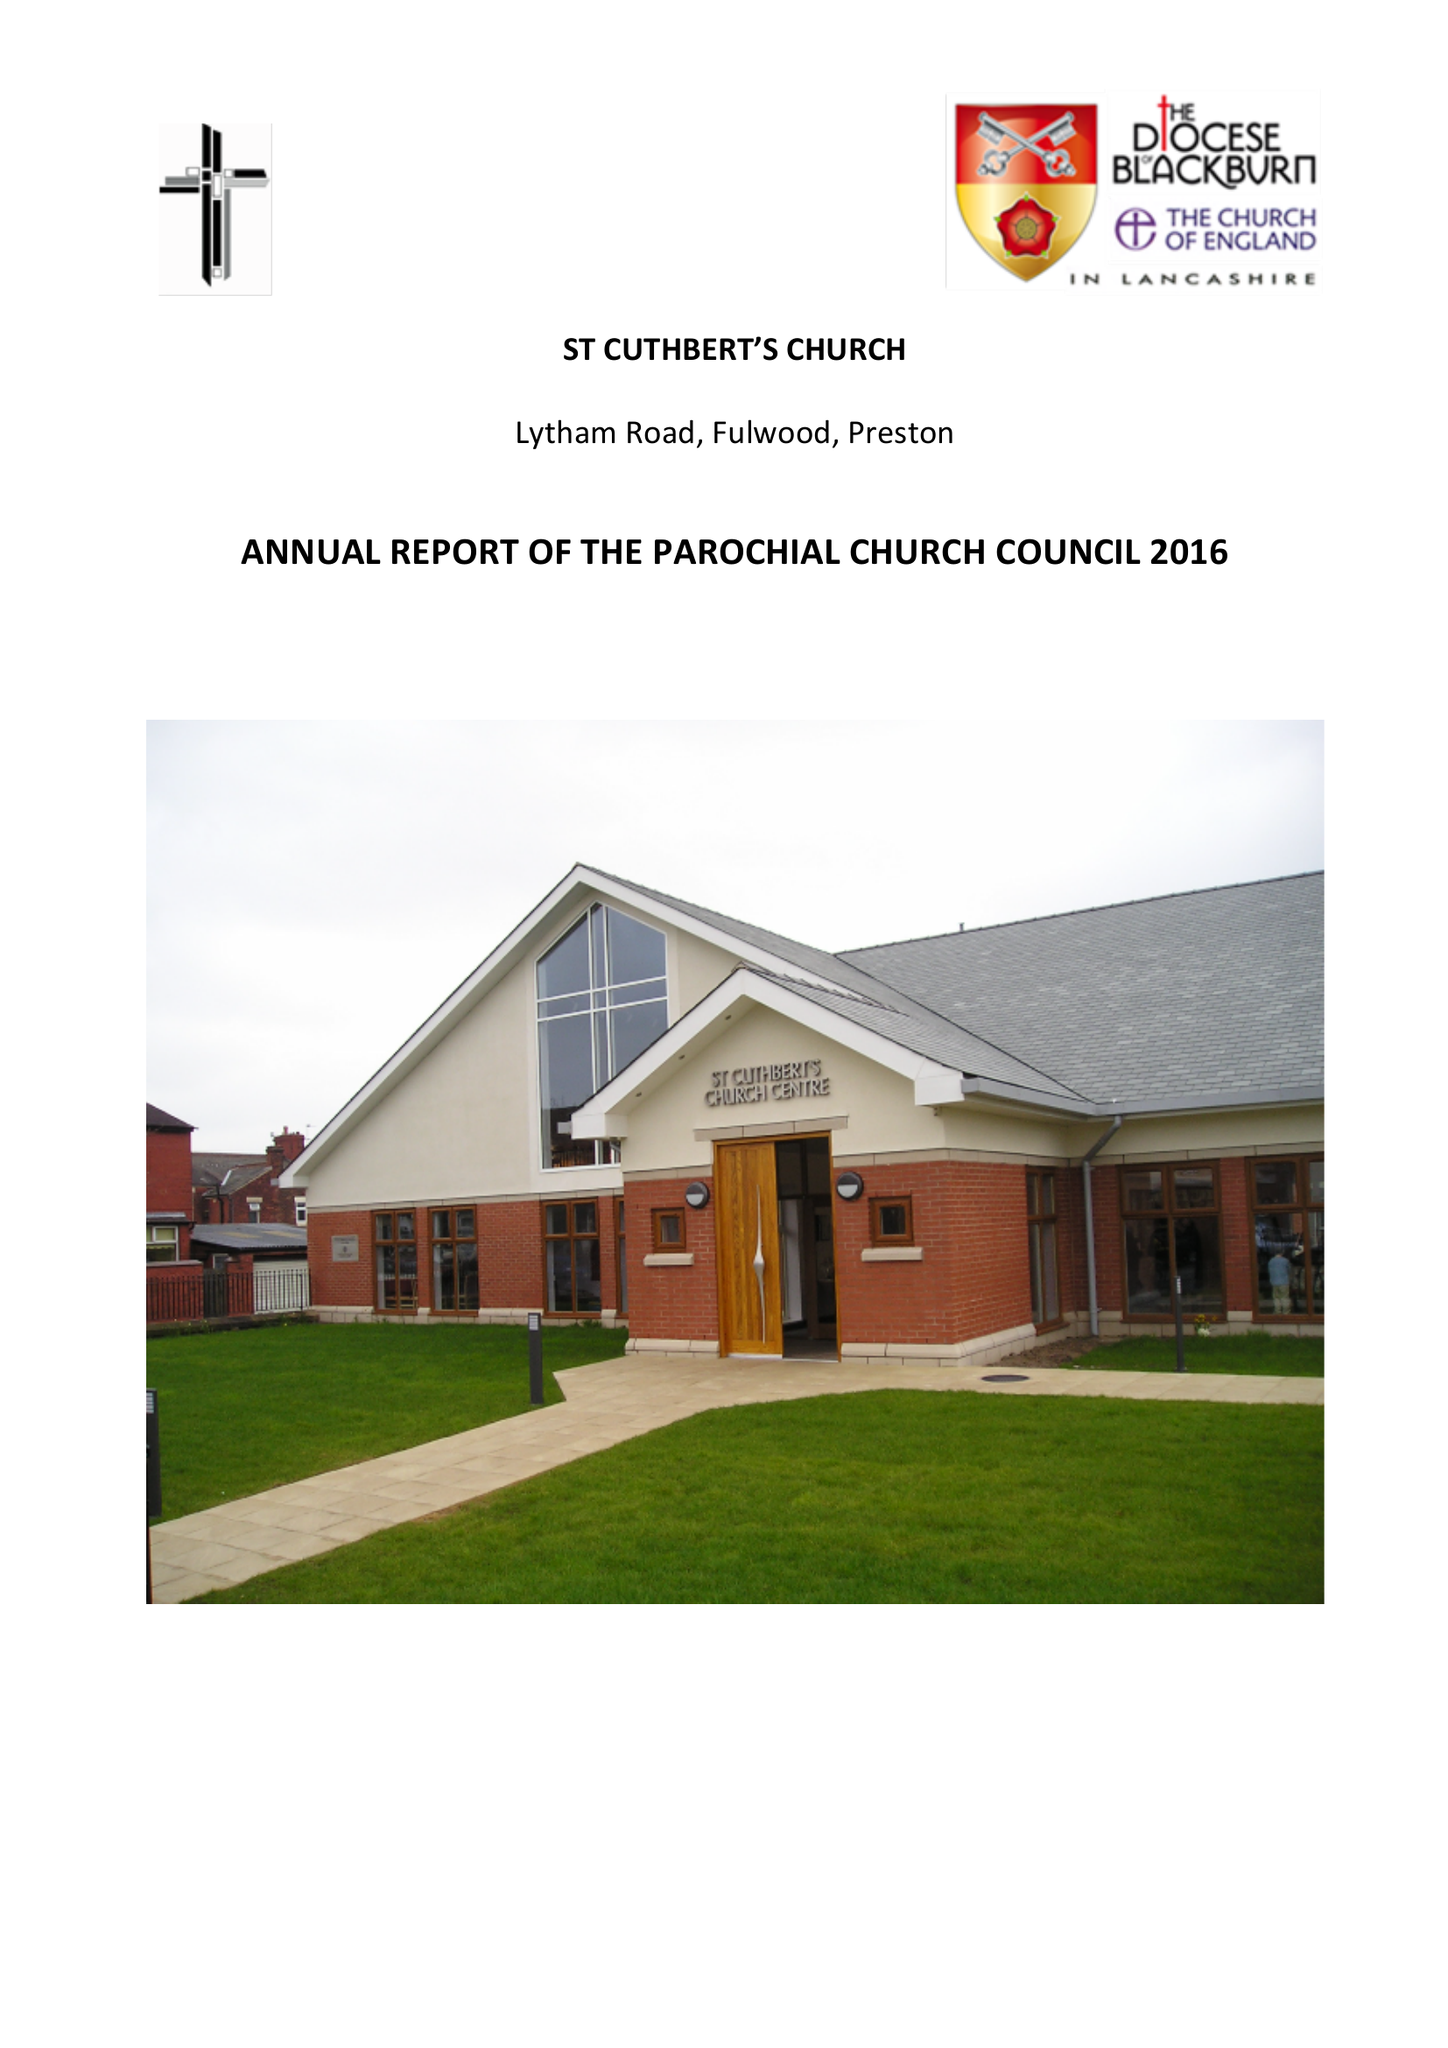What is the value for the income_annually_in_british_pounds?
Answer the question using a single word or phrase. 131738.63 